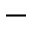<formula> <loc_0><loc_0><loc_500><loc_500>-</formula> 